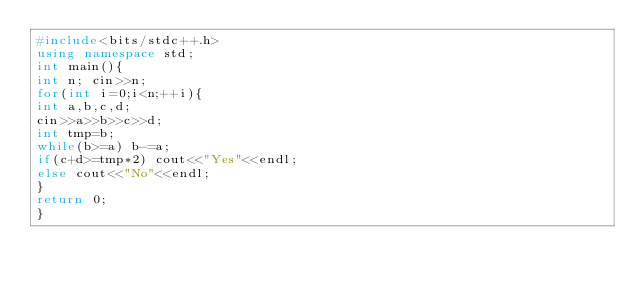Convert code to text. <code><loc_0><loc_0><loc_500><loc_500><_C++_>#include<bits/stdc++.h>
using namespace std;
int main(){
int n; cin>>n;
for(int i=0;i<n;++i){
int a,b,c,d;
cin>>a>>b>>c>>d;
int tmp=b;
while(b>=a) b-=a;
if(c+d>=tmp*2) cout<<"Yes"<<endl;
else cout<<"No"<<endl;
}
return 0;
}</code> 